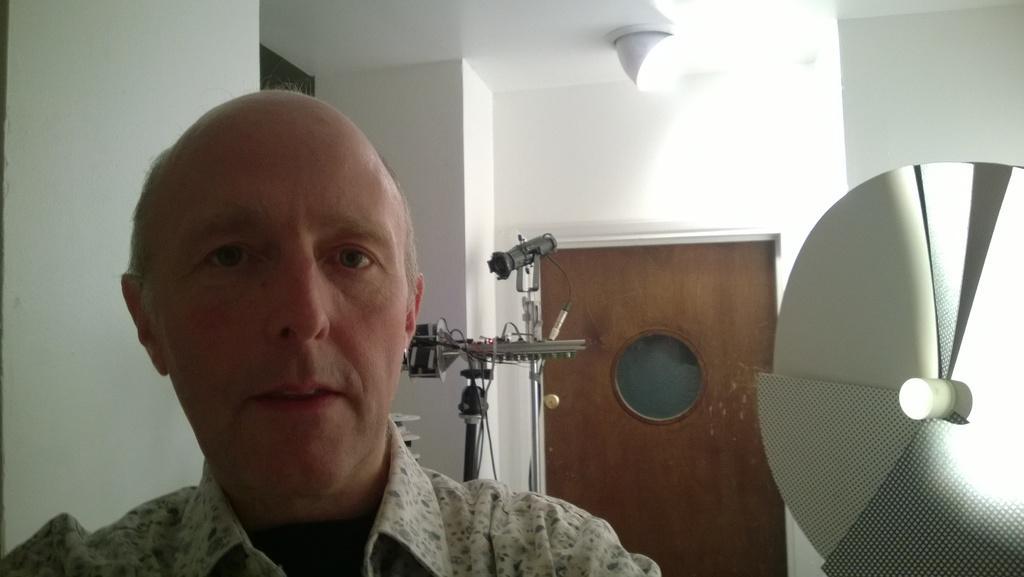Can you describe this image briefly? In this image I see a man and I see an equipment over here and I see the door over here and I see the white wall and I see the light on the ceiling. 